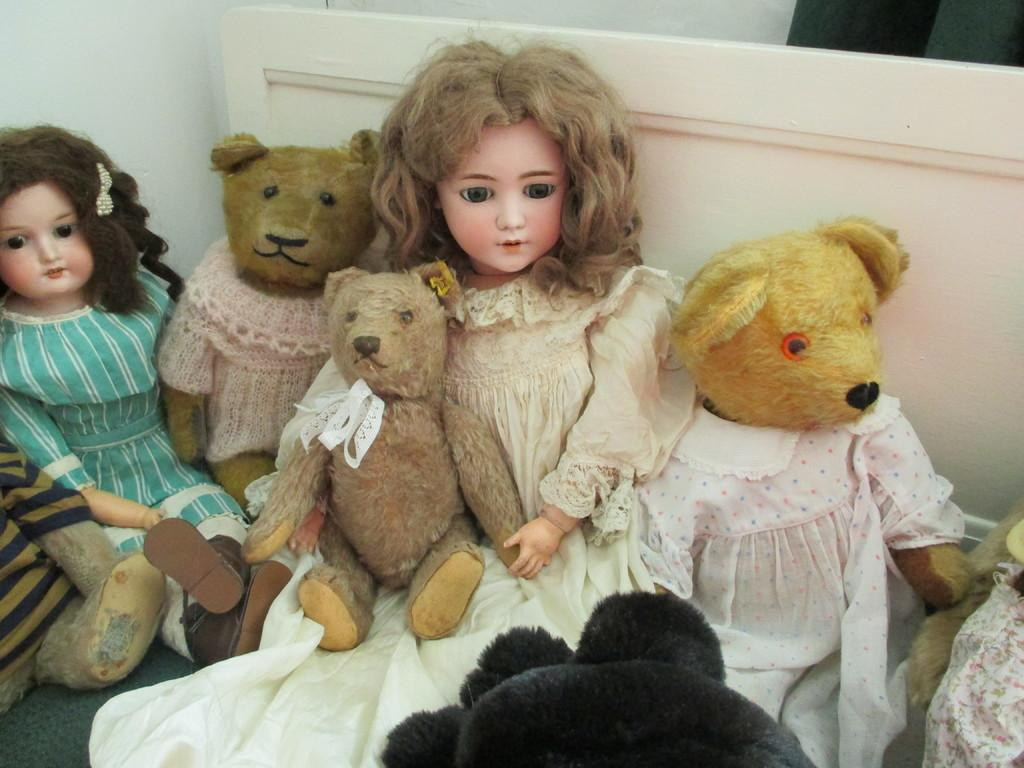What is the main subject of the image? The main subject of the image is a group of dolls. Where are the dolls located in the image? The dolls are placed on the floor. What else can be seen in the image besides the dolls? There is a board and a wall visible in the image. What type of organization is responsible for the waste management in the image? There is no mention of waste management or any organization in the image. 